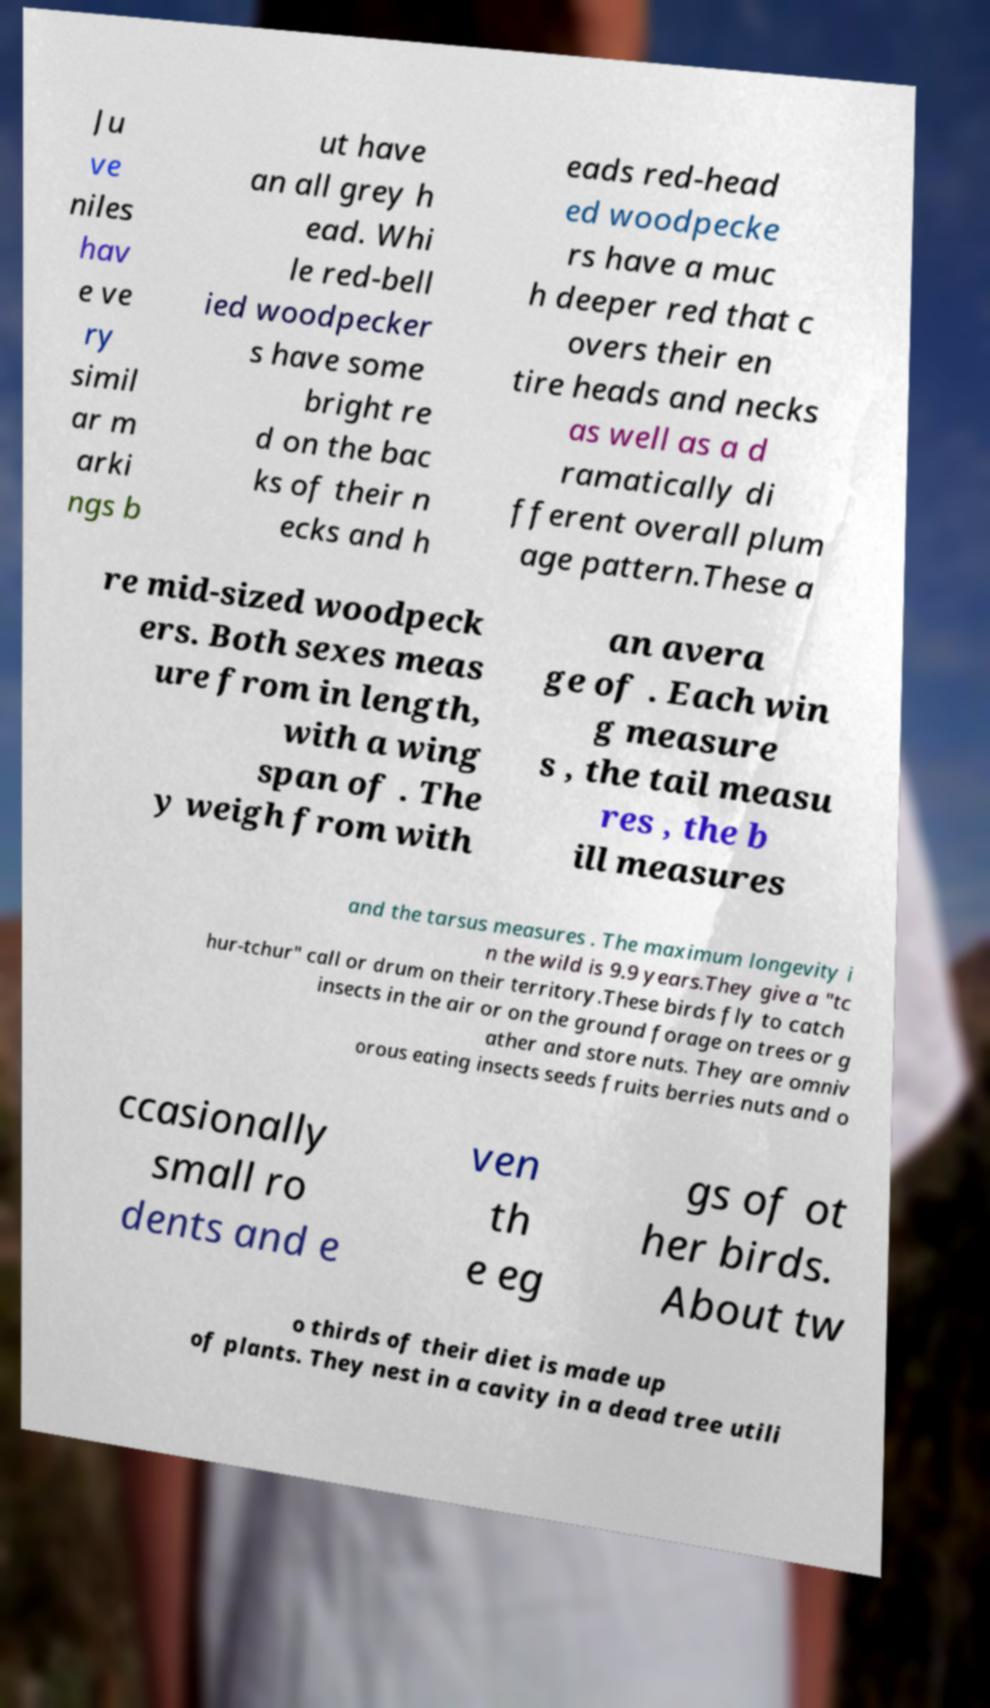Please read and relay the text visible in this image. What does it say? Ju ve niles hav e ve ry simil ar m arki ngs b ut have an all grey h ead. Whi le red-bell ied woodpecker s have some bright re d on the bac ks of their n ecks and h eads red-head ed woodpecke rs have a muc h deeper red that c overs their en tire heads and necks as well as a d ramatically di fferent overall plum age pattern.These a re mid-sized woodpeck ers. Both sexes meas ure from in length, with a wing span of . The y weigh from with an avera ge of . Each win g measure s , the tail measu res , the b ill measures and the tarsus measures . The maximum longevity i n the wild is 9.9 years.They give a "tc hur-tchur" call or drum on their territory.These birds fly to catch insects in the air or on the ground forage on trees or g ather and store nuts. They are omniv orous eating insects seeds fruits berries nuts and o ccasionally small ro dents and e ven th e eg gs of ot her birds. About tw o thirds of their diet is made up of plants. They nest in a cavity in a dead tree utili 